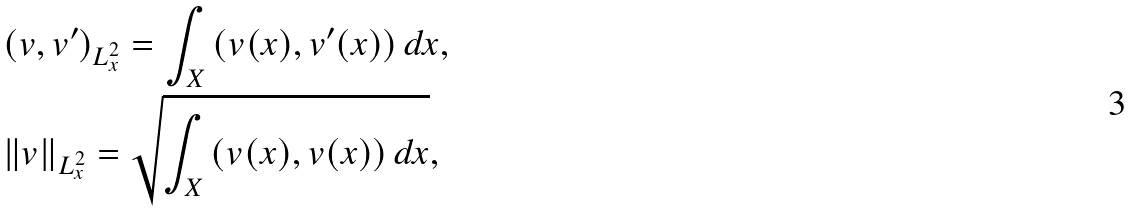<formula> <loc_0><loc_0><loc_500><loc_500>& ( v , v ^ { \prime } ) _ { L ^ { 2 } _ { x } } = \int _ { X } \left ( v ( x ) , v ^ { \prime } ( x ) \right ) d x , \\ & \| v \| _ { L ^ { 2 } _ { x } } = \sqrt { \int _ { X } \left ( v ( x ) , v ( x ) \right ) d x } ,</formula> 